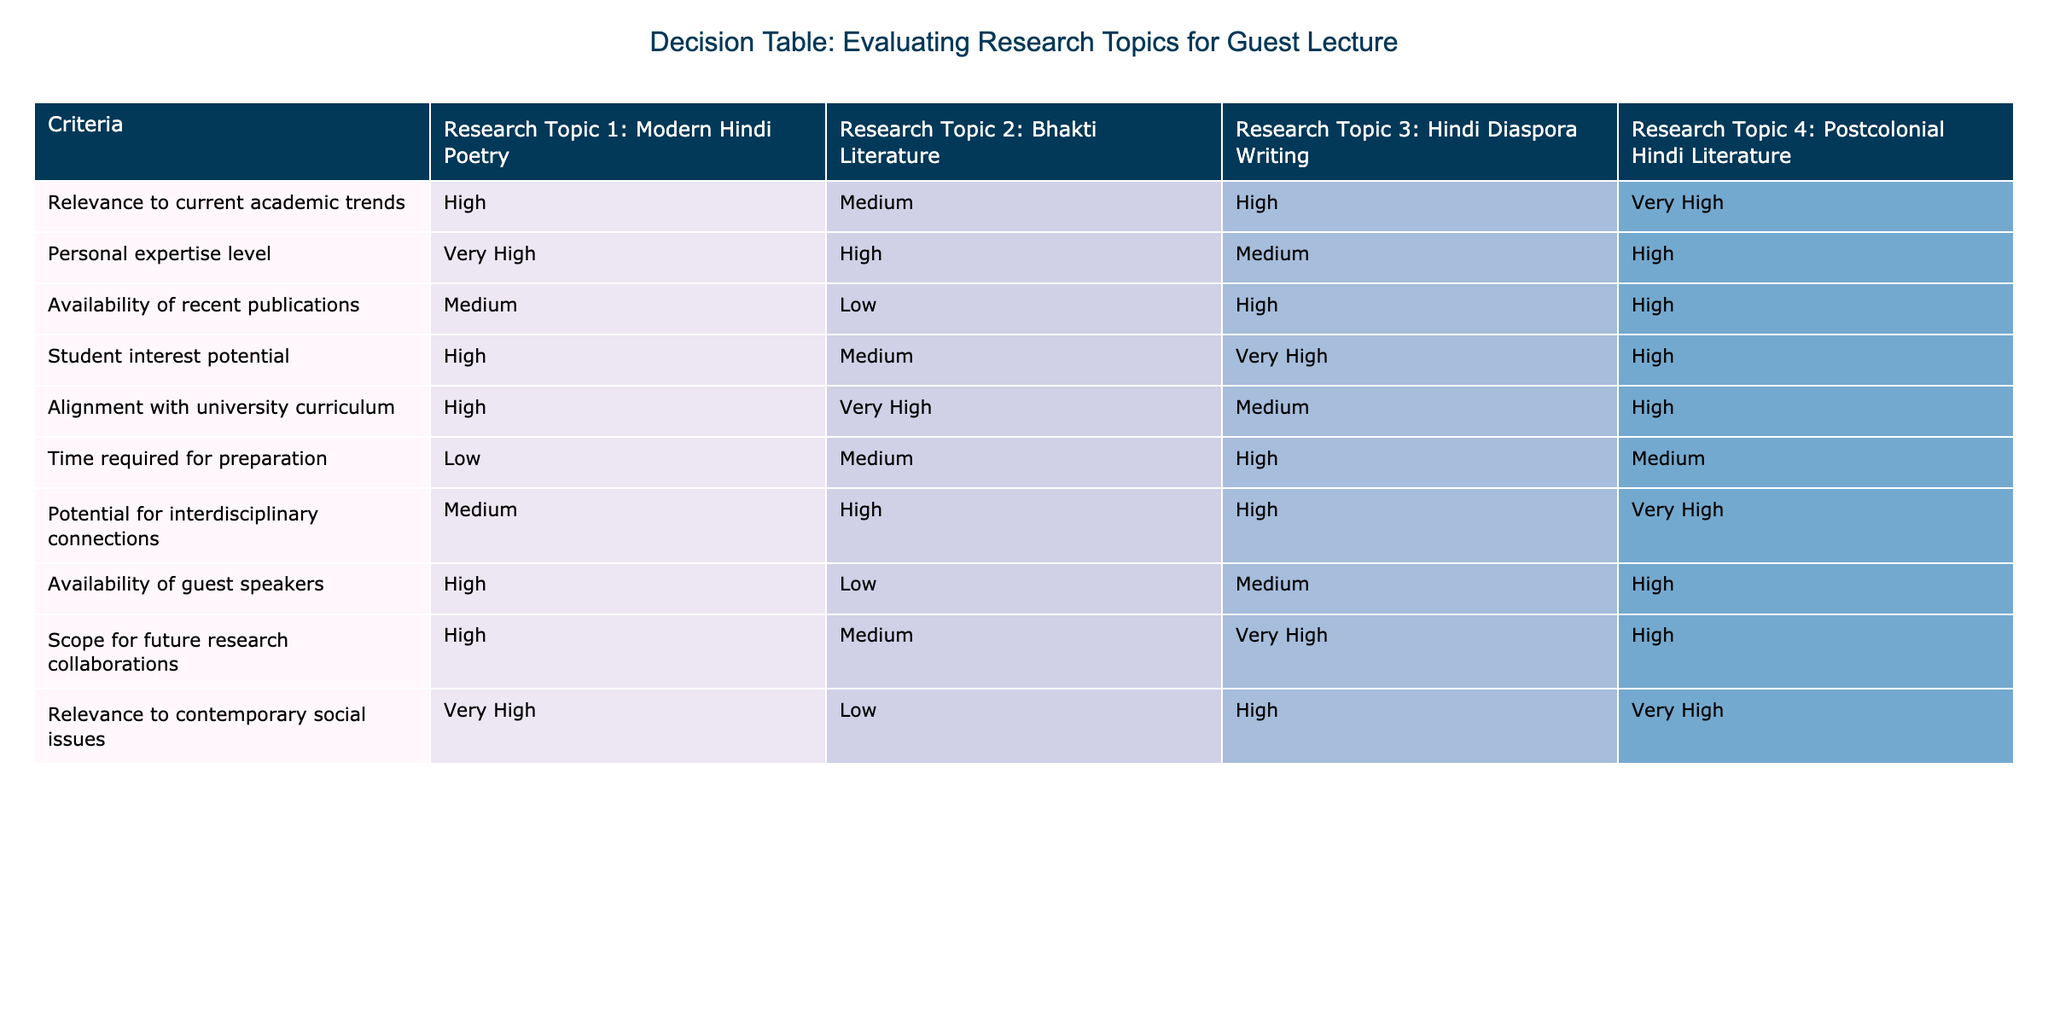What is the relevance of Modern Hindi Poetry to current academic trends? The table shows that the relevance of Modern Hindi Poetry to current academic trends is rated as High.
Answer: High Which research topic has the highest alignment with the university curriculum? The research topics are compared for their alignment with the university curriculum, and Postcolonial Hindi Literature, with a rating of High, along with Bhakti Literature rated as Very High, has the highest alignment.
Answer: Very High Is there a research topic with low availability of recent publications? By examining the table, Bhakti Literature is found to have a low rating for the availability of recent publications.
Answer: Yes How many research topics have High potential for interdisciplinary connections? Looking at the ratings for potential for interdisciplinary connections, we see that there are three topics: Bhakti Literature, Hindi Diaspora Writing, and Postcolonial Hindi Literature, which all have High ratings. Therefore, we total these ratings: 3.
Answer: 3 Which research topic shows the highest student interest potential? By reviewing the student interest potential ratings, Hindi Diaspora Writing has the highest rating of Very High, more than others.
Answer: Very High What is the potential for future research collaborations for Hindi Diaspora Writing, compared to Modern Hindi Poetry? Hindi Diaspora Writing has a rating of Very High, while Modern Hindi Poetry has a High rating. The difference indicates that Hindi Diaspora Writing has a higher potential by one level.
Answer: Higher by one level Which research topic is the least prepared with time required? The table indicates that Hindi Diaspora Writing requires the most time for preparation with a rating of High compared to others which are either Low or Medium.
Answer: Hindi Diaspora Writing Is there a research topic that lacks relevance to contemporary social issues? The data indicates that Bhakti Literature is rated Low for relevance to contemporary social issues, suggesting it lacks relevance.
Answer: Yes What is the average score for relevance to current academic trends across all research topics? We need to convert the qualitative ratings to a numerical scale (e.g., Very High=4, High=3, Medium=2, Low=1). The scores are: Modern Hindi Poetry (3), Bhakti Literature (2), Hindi Diaspora Writing (3), Postcolonial Hindi Literature (4). The average is calculated as (3 + 2 + 3 + 4) / 4 = 3.
Answer: 3 